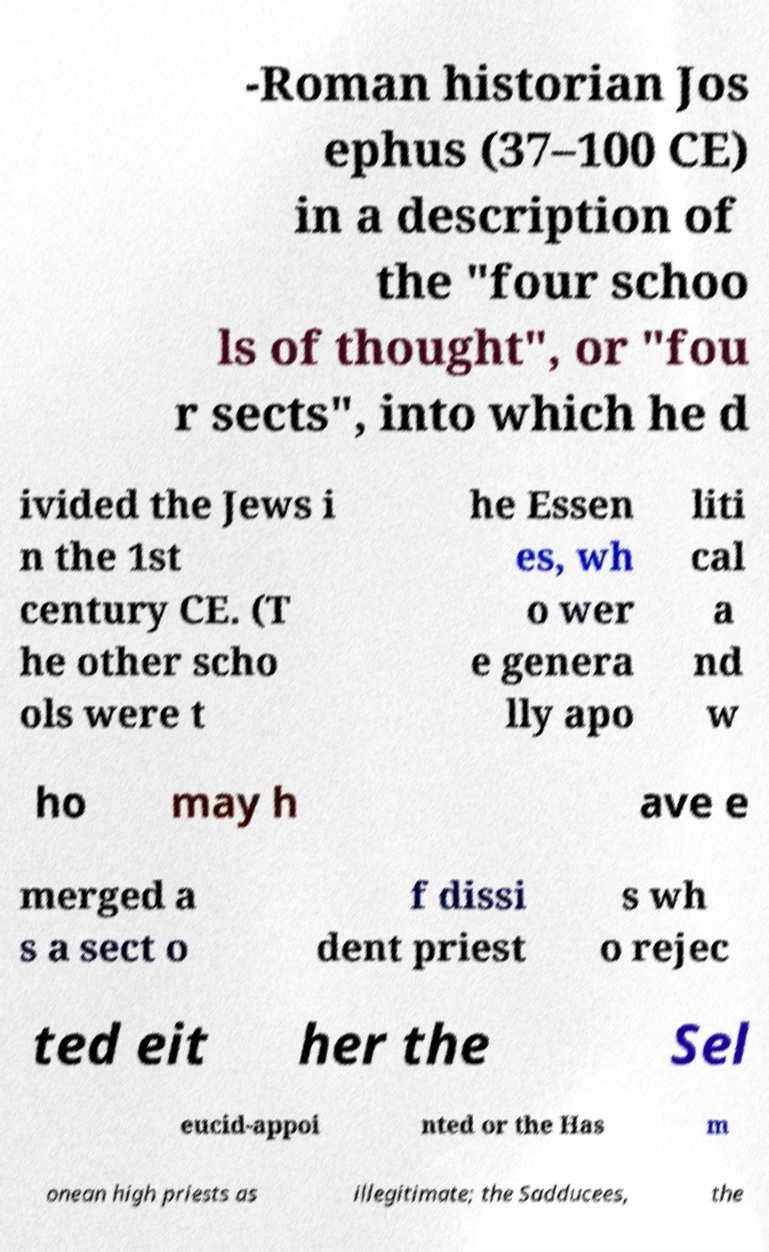Could you assist in decoding the text presented in this image and type it out clearly? -Roman historian Jos ephus (37–100 CE) in a description of the "four schoo ls of thought", or "fou r sects", into which he d ivided the Jews i n the 1st century CE. (T he other scho ols were t he Essen es, wh o wer e genera lly apo liti cal a nd w ho may h ave e merged a s a sect o f dissi dent priest s wh o rejec ted eit her the Sel eucid-appoi nted or the Has m onean high priests as illegitimate; the Sadducees, the 